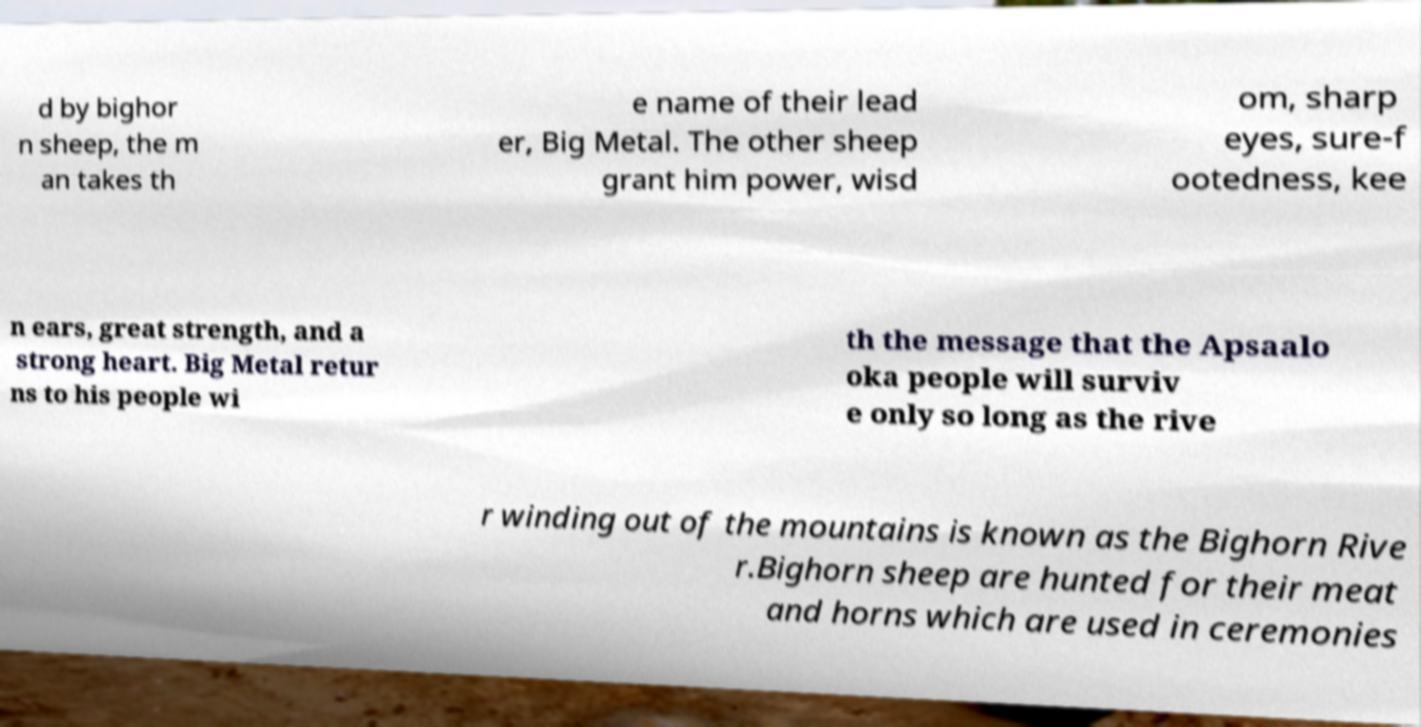What messages or text are displayed in this image? I need them in a readable, typed format. d by bighor n sheep, the m an takes th e name of their lead er, Big Metal. The other sheep grant him power, wisd om, sharp eyes, sure-f ootedness, kee n ears, great strength, and a strong heart. Big Metal retur ns to his people wi th the message that the Apsaalo oka people will surviv e only so long as the rive r winding out of the mountains is known as the Bighorn Rive r.Bighorn sheep are hunted for their meat and horns which are used in ceremonies 